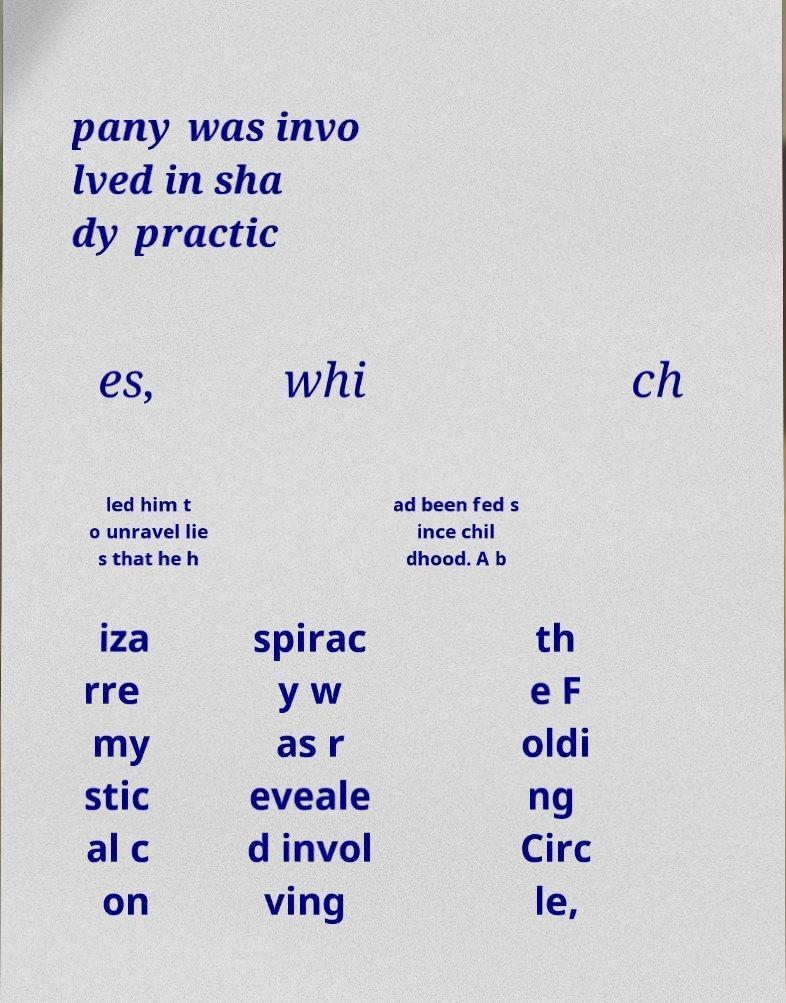There's text embedded in this image that I need extracted. Can you transcribe it verbatim? pany was invo lved in sha dy practic es, whi ch led him t o unravel lie s that he h ad been fed s ince chil dhood. A b iza rre my stic al c on spirac y w as r eveale d invol ving th e F oldi ng Circ le, 